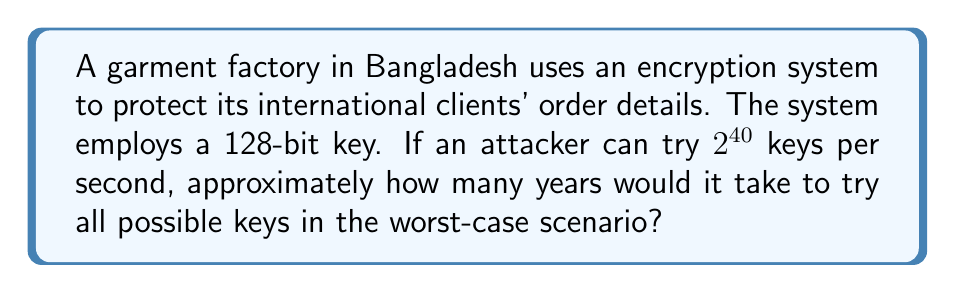Teach me how to tackle this problem. Let's approach this step-by-step:

1) First, we need to calculate the total number of possible keys:
   For a 128-bit key, there are $2^{128}$ possible combinations.

2) Now, we need to calculate how many keys can be tried in a year:
   Keys per second = $2^{40}$
   Seconds in a year = 365 * 24 * 60 * 60 = 31,536,000

   Keys tried in a year = $2^{40} * 31,536,000$

3) To find the number of years, we divide the total number of keys by the keys tried in a year:

   Years = $\frac{2^{128}}{2^{40} * 31,536,000}$

4) Simplify:
   $\frac{2^{128}}{2^{40} * 31,536,000} = \frac{2^{88}}{31,536,000}$

5) Calculate:
   $2^{88} \approx 3.09 * 10^{26}$
   $\frac{3.09 * 10^{26}}{31,536,000} \approx 9.79 * 10^{18}$ years

6) This is approximately $9.79 * 10^{18}$ years or 9.79 quintillion years.
Answer: $9.79 * 10^{18}$ years 